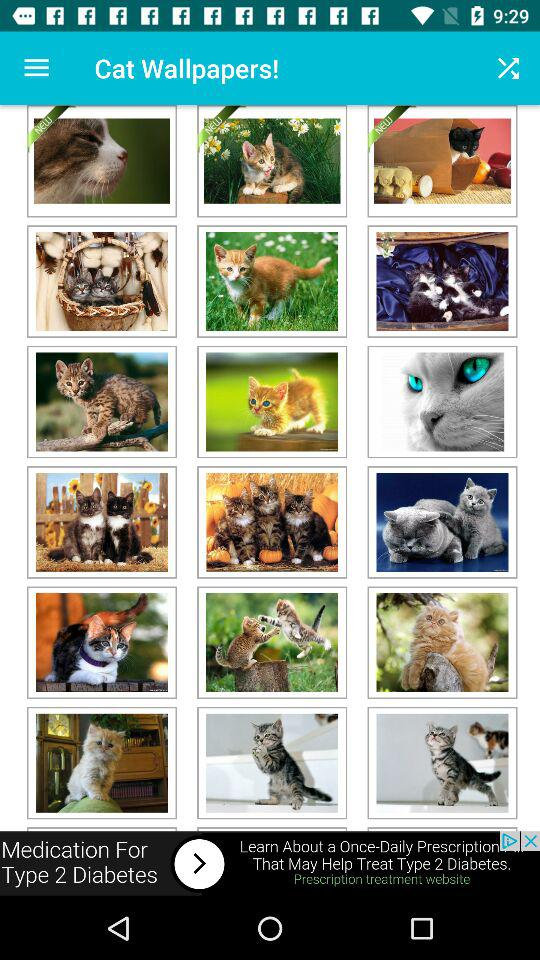What is the application name? The application name is "Cat Wallpapers!". 